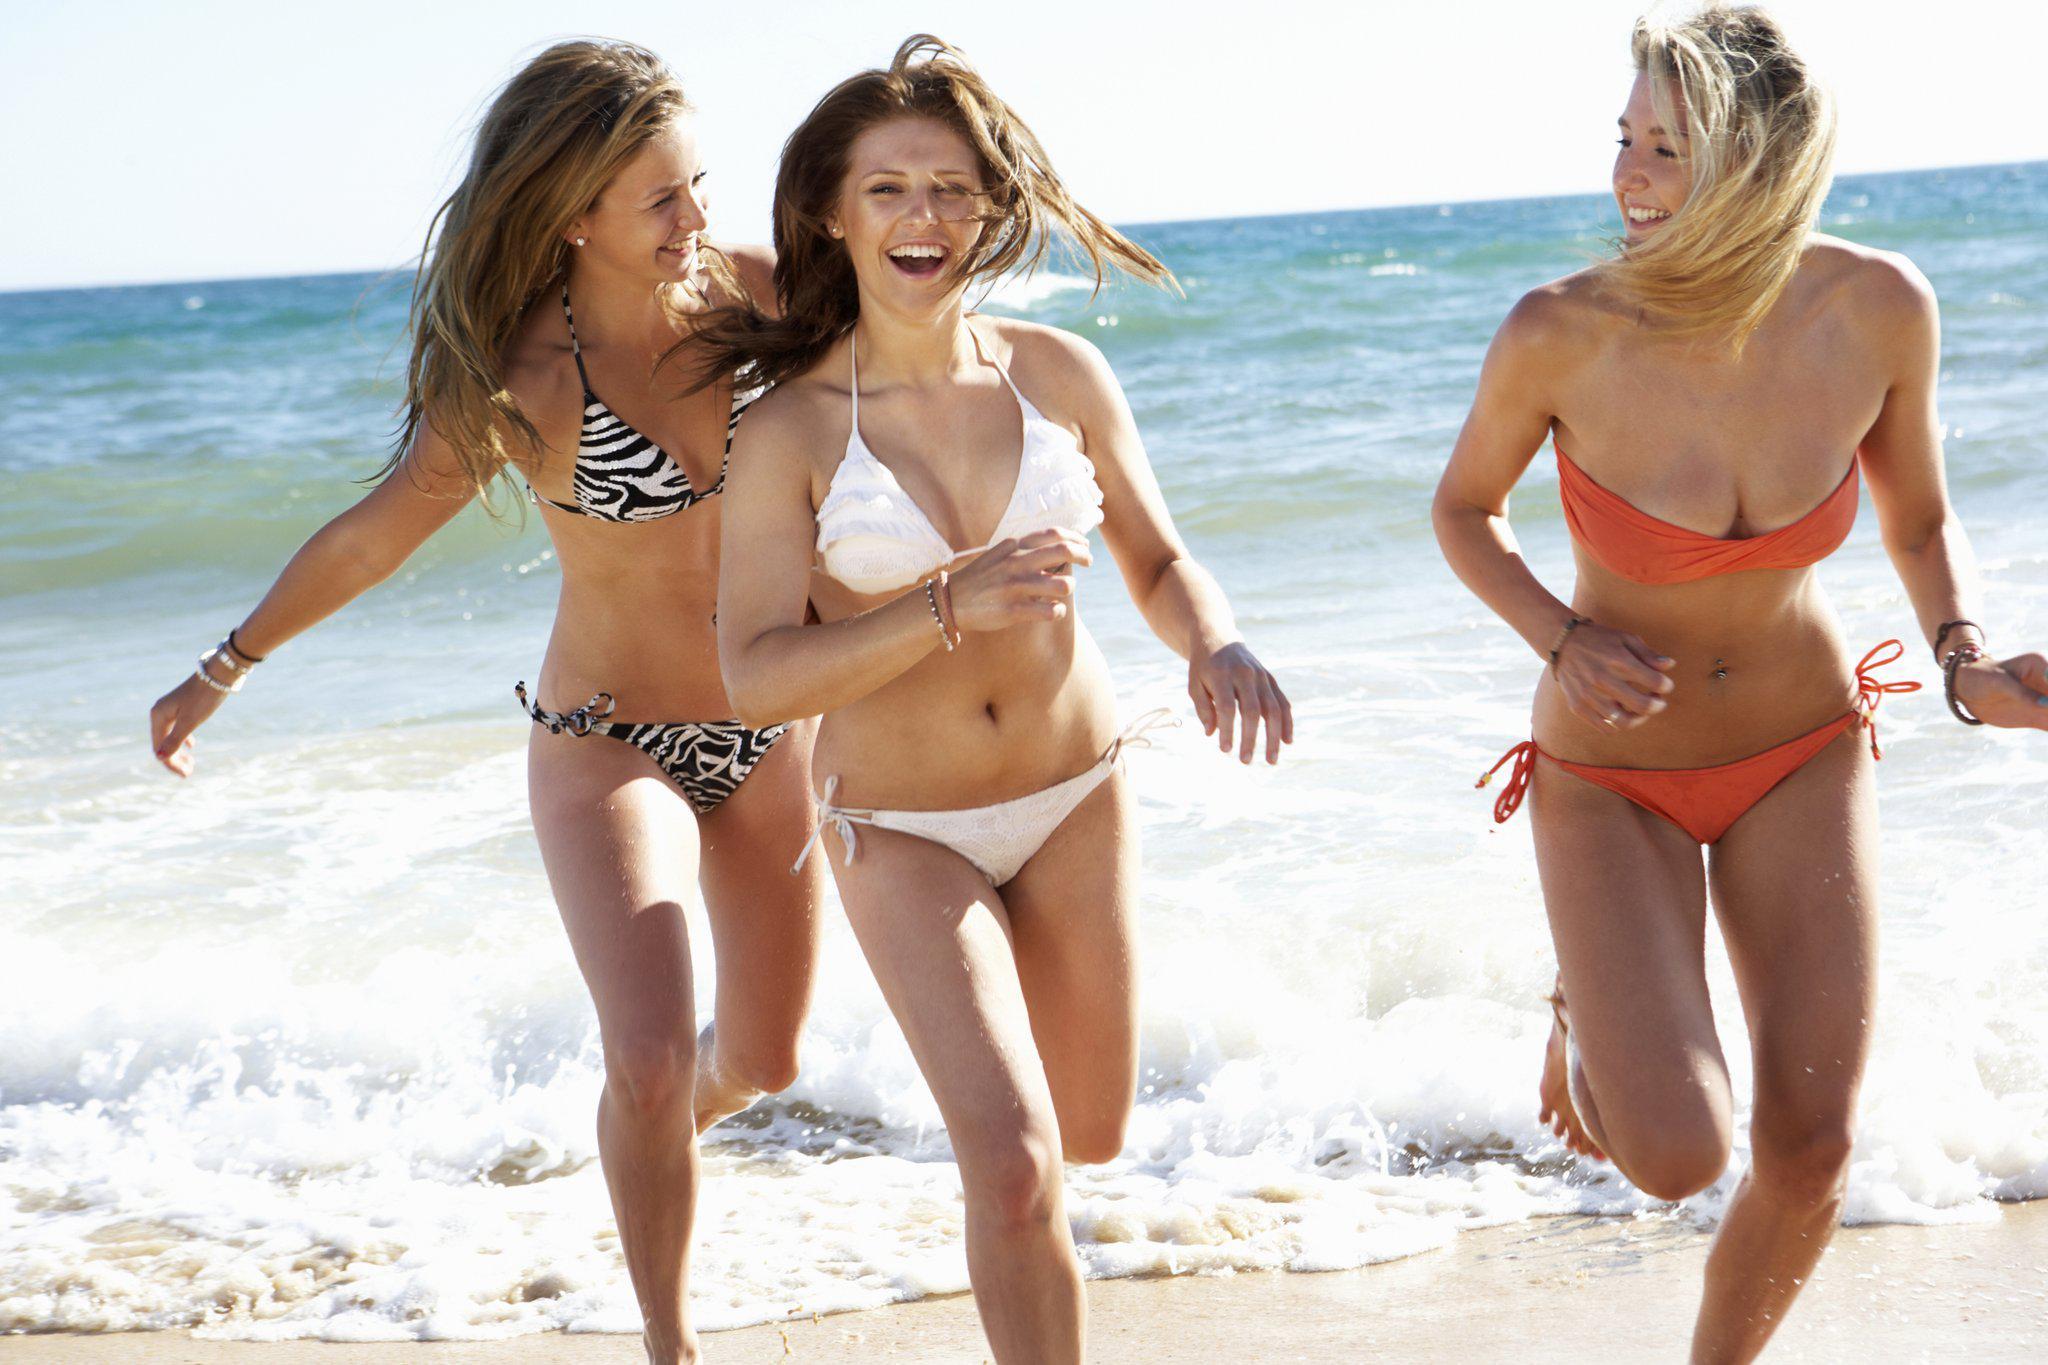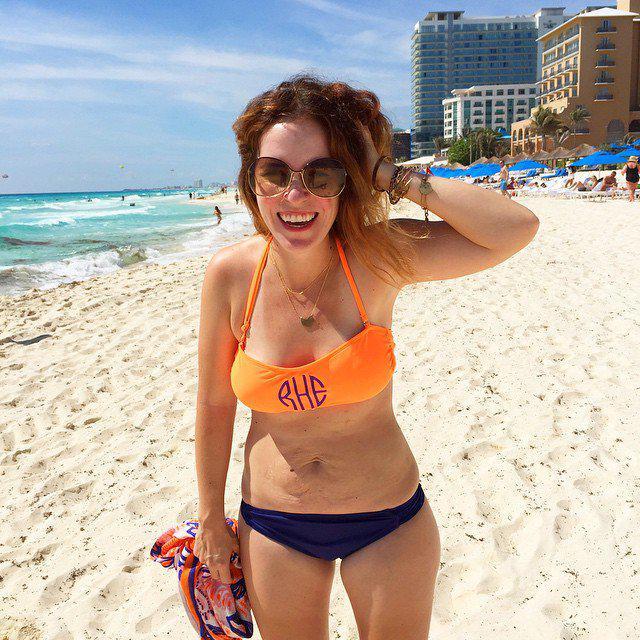The first image is the image on the left, the second image is the image on the right. Examine the images to the left and right. Is the description "One of the images contains exactly two women in swimsuits." accurate? Answer yes or no. No. The first image is the image on the left, the second image is the image on the right. Given the left and right images, does the statement "One image contains exactly three bikini models, and the other image contains no more than two bikini models and includes a blue bikini bottom and an orange bikini top." hold true? Answer yes or no. Yes. 